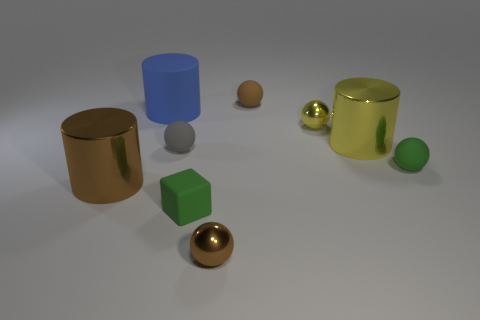Can you describe the lighting in the scene? The lighting in the scene appears to be soft and diffused, coming from a source that is not directly visible in the image. The gentle shadows and subtle highlights on the objects suggest an evenly distributed light source, providing clarity without harsh contrasts. 